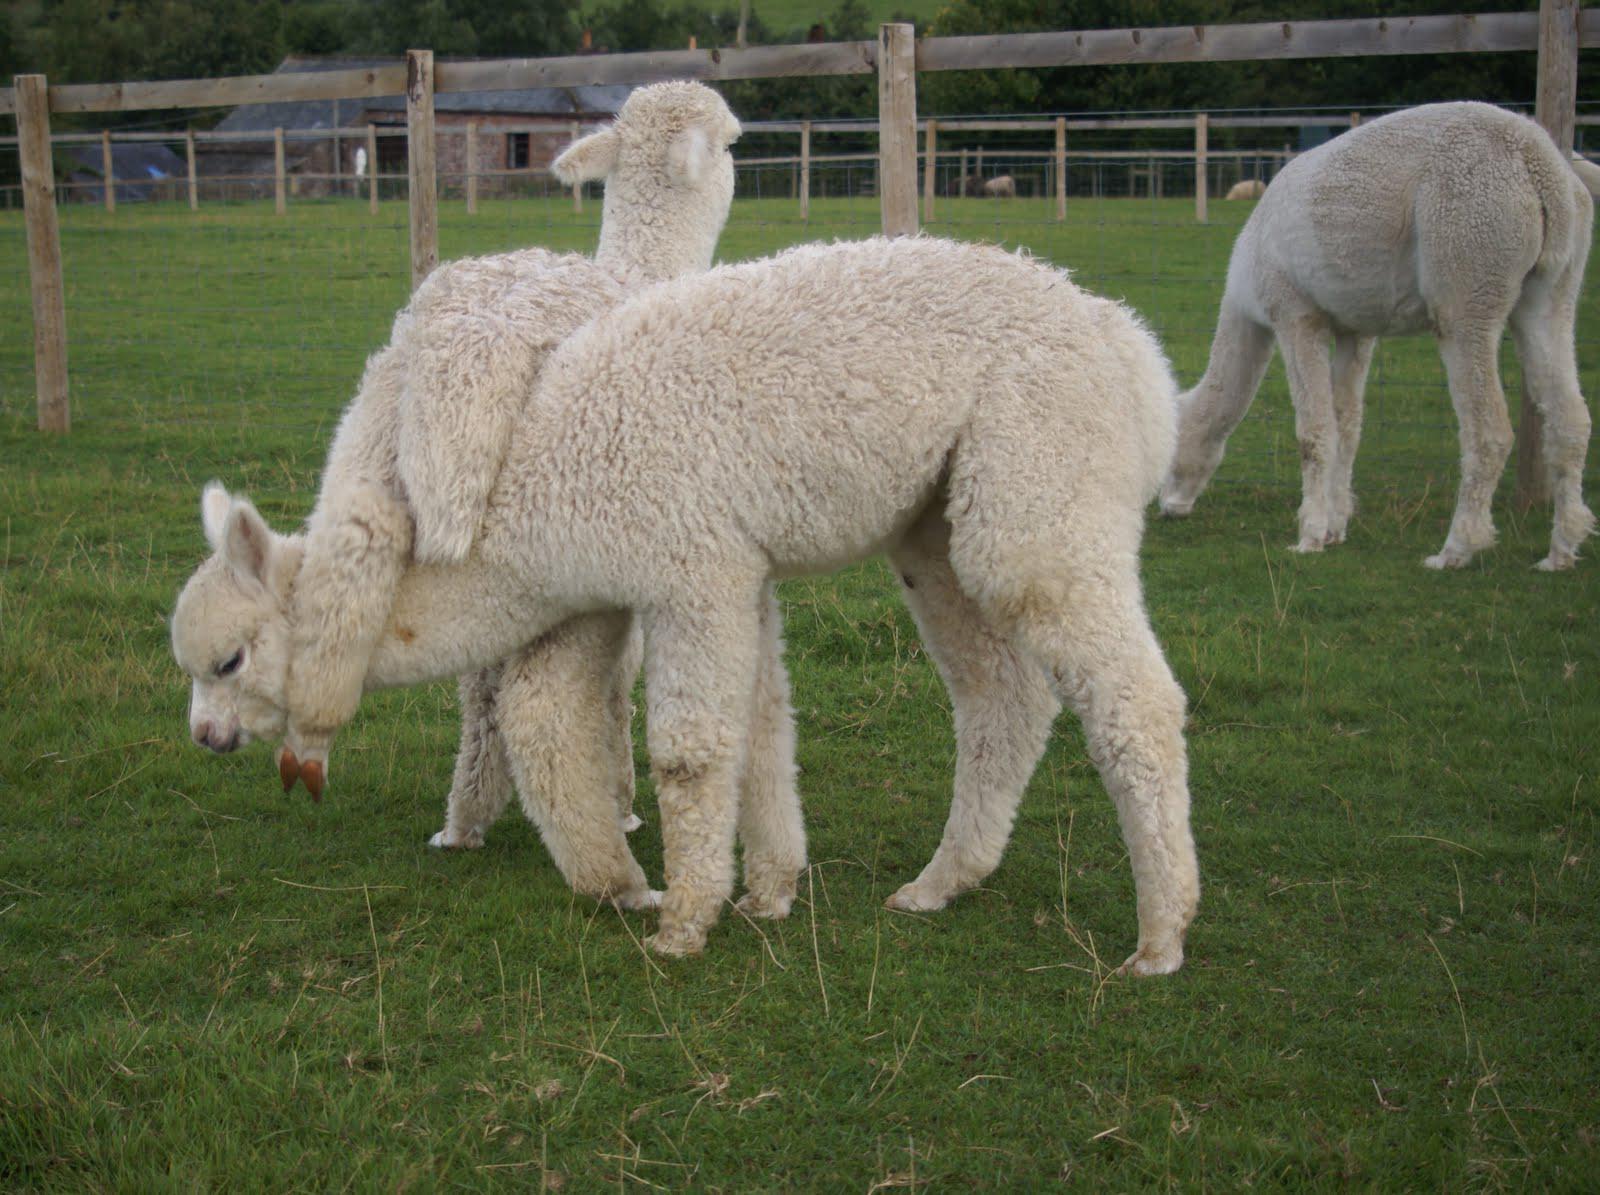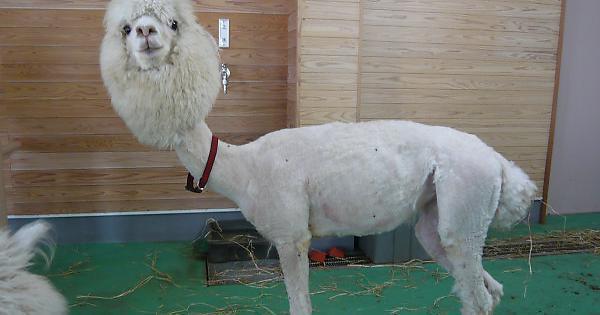The first image is the image on the left, the second image is the image on the right. Considering the images on both sides, is "In one of the images, there is a soccer ball between a person and a llama." valid? Answer yes or no. No. The first image is the image on the left, the second image is the image on the right. Analyze the images presented: Is the assertion "One image shows a person in blue pants standing to the left of a brown llama, with a soccer ball on the ground between them." valid? Answer yes or no. No. 